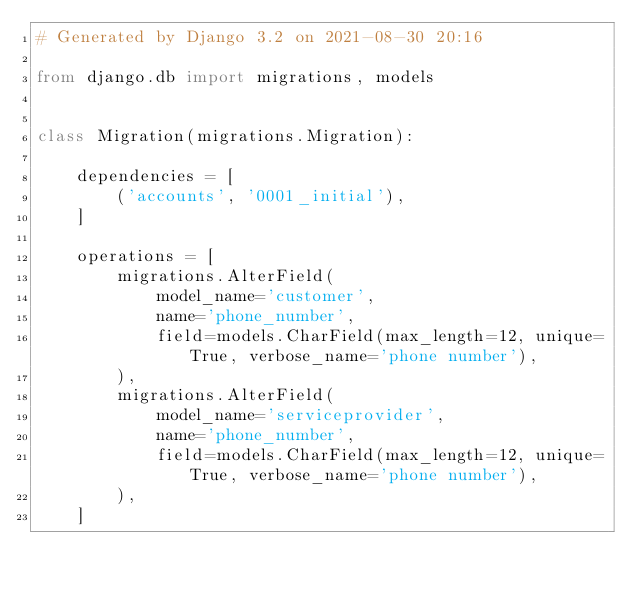Convert code to text. <code><loc_0><loc_0><loc_500><loc_500><_Python_># Generated by Django 3.2 on 2021-08-30 20:16

from django.db import migrations, models


class Migration(migrations.Migration):

    dependencies = [
        ('accounts', '0001_initial'),
    ]

    operations = [
        migrations.AlterField(
            model_name='customer',
            name='phone_number',
            field=models.CharField(max_length=12, unique=True, verbose_name='phone number'),
        ),
        migrations.AlterField(
            model_name='serviceprovider',
            name='phone_number',
            field=models.CharField(max_length=12, unique=True, verbose_name='phone number'),
        ),
    ]
</code> 